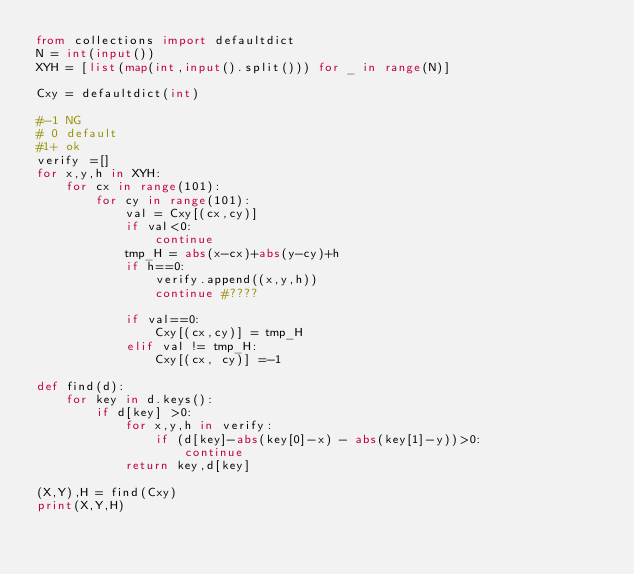<code> <loc_0><loc_0><loc_500><loc_500><_Python_>from collections import defaultdict
N = int(input())
XYH = [list(map(int,input().split())) for _ in range(N)]

Cxy = defaultdict(int)

#-1 NG
# 0 default
#1+ ok
verify =[]
for x,y,h in XYH:
    for cx in range(101):
        for cy in range(101):
            val = Cxy[(cx,cy)]
            if val<0:
                continue
            tmp_H = abs(x-cx)+abs(y-cy)+h
            if h==0:
                verify.append((x,y,h))
                continue #????

            if val==0:
                Cxy[(cx,cy)] = tmp_H
            elif val != tmp_H:
                Cxy[(cx, cy)] =-1

def find(d):
    for key in d.keys():
        if d[key] >0:
            for x,y,h in verify:
                if (d[key]-abs(key[0]-x) - abs(key[1]-y))>0:
                    continue
            return key,d[key]

(X,Y),H = find(Cxy)
print(X,Y,H)</code> 